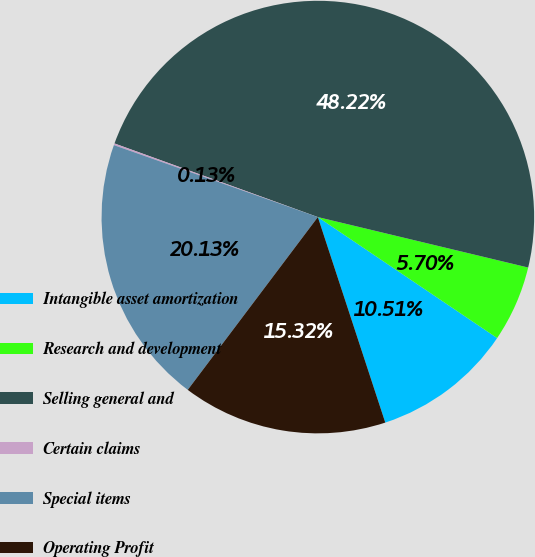<chart> <loc_0><loc_0><loc_500><loc_500><pie_chart><fcel>Intangible asset amortization<fcel>Research and development<fcel>Selling general and<fcel>Certain claims<fcel>Special items<fcel>Operating Profit<nl><fcel>10.51%<fcel>5.7%<fcel>48.23%<fcel>0.13%<fcel>20.13%<fcel>15.32%<nl></chart> 